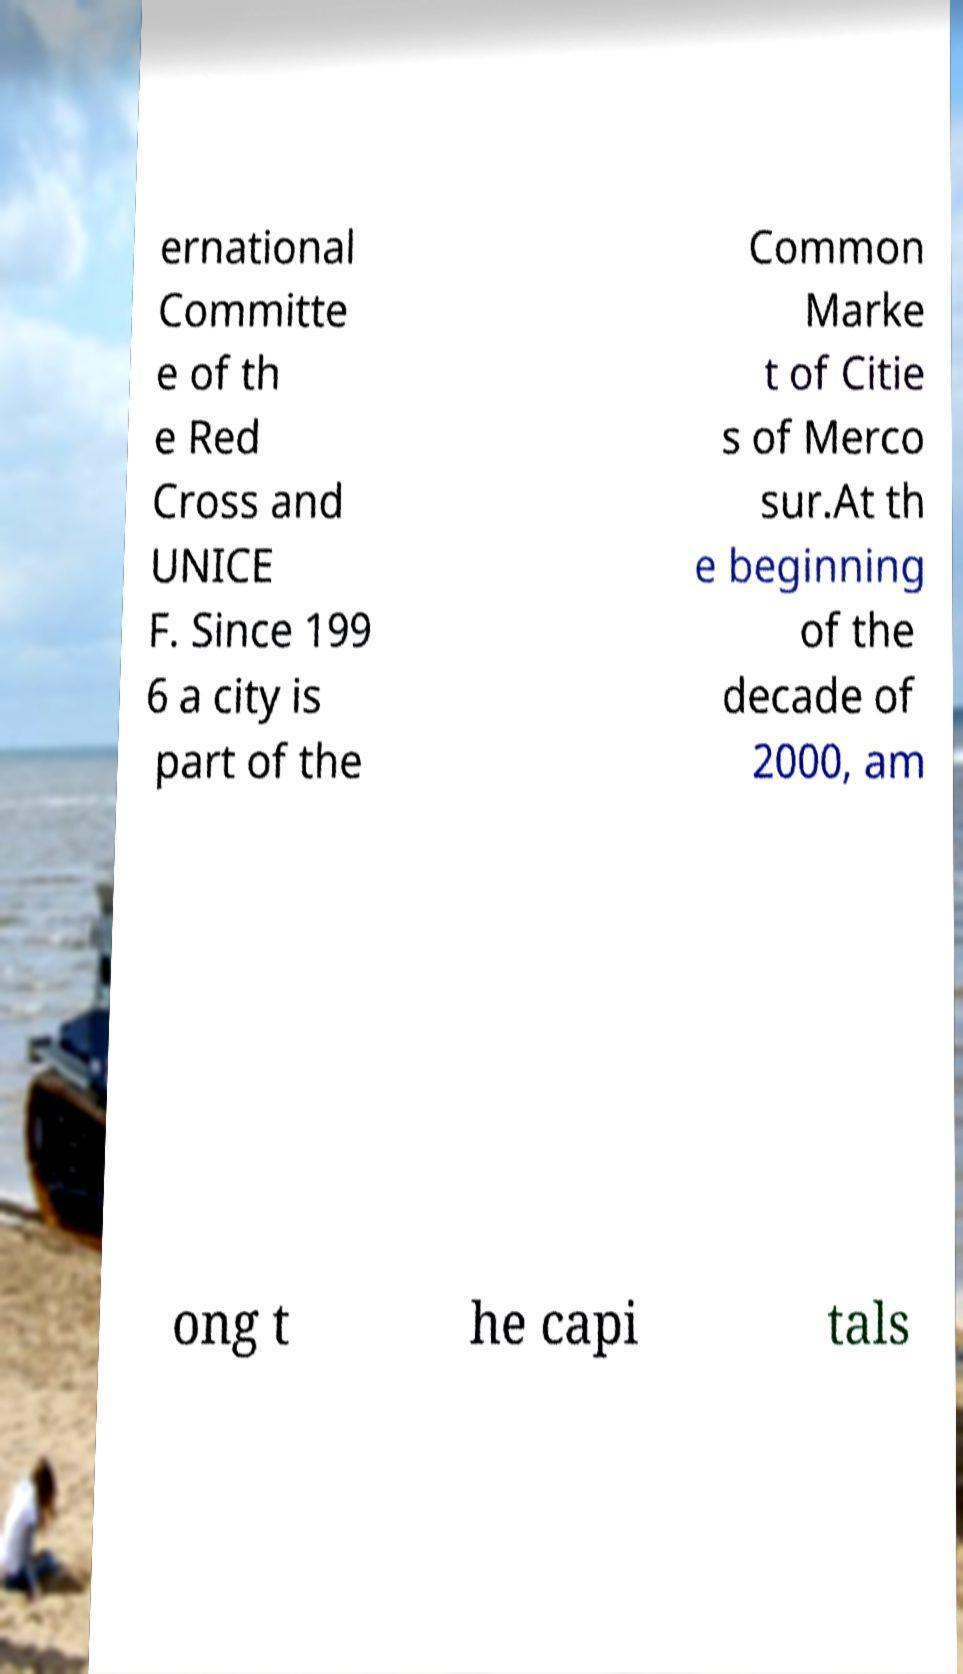Please identify and transcribe the text found in this image. ernational Committe e of th e Red Cross and UNICE F. Since 199 6 a city is part of the Common Marke t of Citie s of Merco sur.At th e beginning of the decade of 2000, am ong t he capi tals 